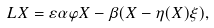Convert formula to latex. <formula><loc_0><loc_0><loc_500><loc_500>L X = \varepsilon \alpha \varphi X - \beta ( X - \eta ( X ) \xi ) ,</formula> 